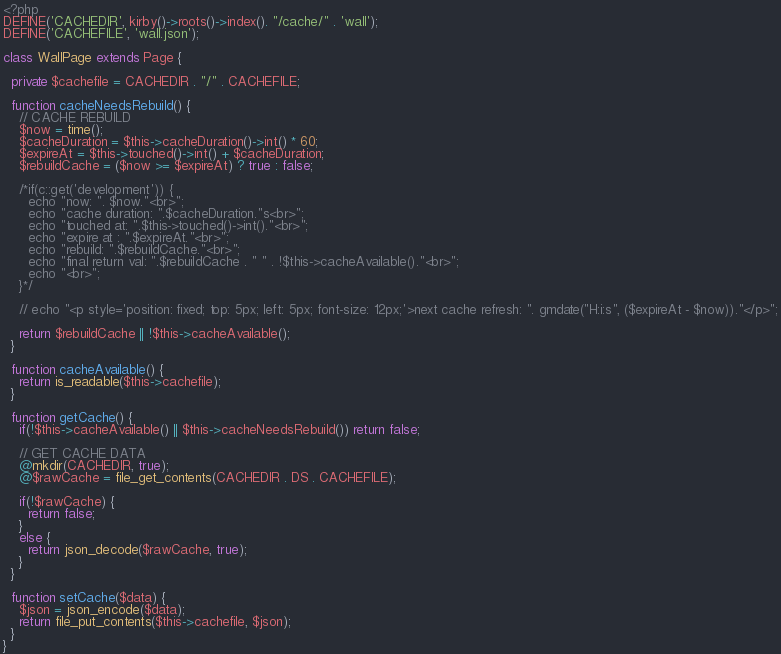<code> <loc_0><loc_0><loc_500><loc_500><_PHP_><?php
DEFINE('CACHEDIR', kirby()->roots()->index(). "/cache/" . 'wall');
DEFINE('CACHEFILE', 'wall.json');

class WallPage extends Page {

  private $cachefile = CACHEDIR . "/" . CACHEFILE;

  function cacheNeedsRebuild() {
    // CACHE REBUILD
    $now = time();
    $cacheDuration = $this->cacheDuration()->int() * 60;
    $expireAt = $this->touched()->int() + $cacheDuration;
    $rebuildCache = ($now >= $expireAt) ? true : false;

    /*if(c::get('development')) {
      echo "now: ". $now."<br>";
      echo "cache duration: ".$cacheDuration."s<br>";
      echo "touched at: ".$this->touched()->int()."<br>";
      echo "expire at : ".$expireAt."<br>";
      echo "rebuild: ".$rebuildCache."<br>";
      echo "final return val: ".$rebuildCache . " " . !$this->cacheAvailable()."<br>";
      echo "<br>";
    }*/

    // echo "<p style='position: fixed; top: 5px; left: 5px; font-size: 12px;'>next cache refresh: ". gmdate("H:i:s", ($expireAt - $now))."</p>";

    return $rebuildCache || !$this->cacheAvailable();
  }

  function cacheAvailable() {
    return is_readable($this->cachefile);
  }

  function getCache() {
    if(!$this->cacheAvailable() || $this->cacheNeedsRebuild()) return false;

    // GET CACHE DATA
    @mkdir(CACHEDIR, true);
    @$rawCache = file_get_contents(CACHEDIR . DS . CACHEFILE);

    if(!$rawCache) {
      return false;
    }
    else {
      return json_decode($rawCache, true);
    }
  }

  function setCache($data) {
    $json = json_encode($data);
    return file_put_contents($this->cachefile, $json);
  }
}
</code> 